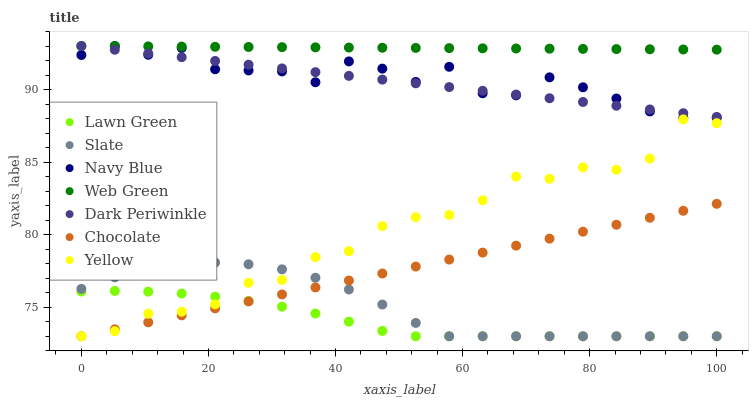Does Lawn Green have the minimum area under the curve?
Answer yes or no. Yes. Does Web Green have the maximum area under the curve?
Answer yes or no. Yes. Does Navy Blue have the minimum area under the curve?
Answer yes or no. No. Does Navy Blue have the maximum area under the curve?
Answer yes or no. No. Is Web Green the smoothest?
Answer yes or no. Yes. Is Navy Blue the roughest?
Answer yes or no. Yes. Is Slate the smoothest?
Answer yes or no. No. Is Slate the roughest?
Answer yes or no. No. Does Lawn Green have the lowest value?
Answer yes or no. Yes. Does Navy Blue have the lowest value?
Answer yes or no. No. Does Dark Periwinkle have the highest value?
Answer yes or no. Yes. Does Slate have the highest value?
Answer yes or no. No. Is Chocolate less than Dark Periwinkle?
Answer yes or no. Yes. Is Dark Periwinkle greater than Lawn Green?
Answer yes or no. Yes. Does Dark Periwinkle intersect Navy Blue?
Answer yes or no. Yes. Is Dark Periwinkle less than Navy Blue?
Answer yes or no. No. Is Dark Periwinkle greater than Navy Blue?
Answer yes or no. No. Does Chocolate intersect Dark Periwinkle?
Answer yes or no. No. 